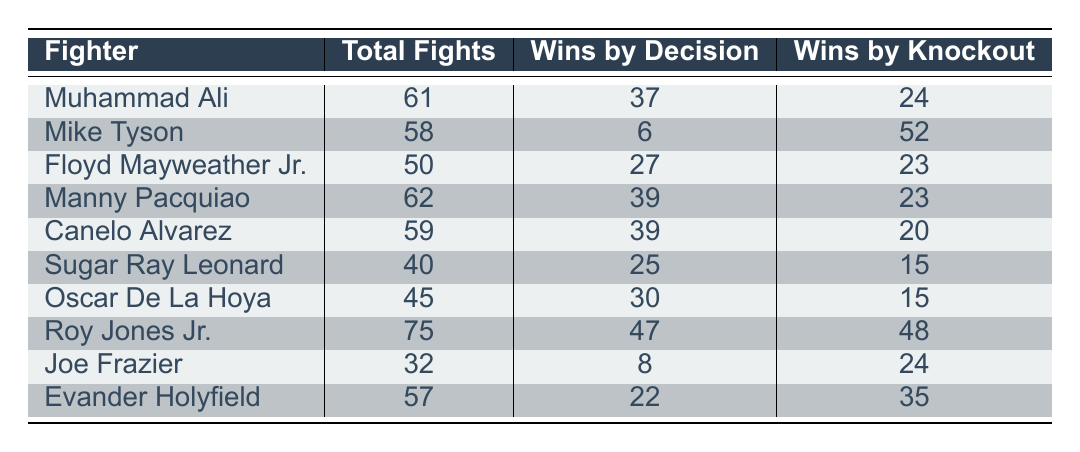What is the total number of fights won by Muhammad Ali? The table shows that Muhammad Ali had a total of 61 fights. Among these fights, he won 37 by decision and 24 by knockout. To find the total number of wins, we simply recognize that the table lists his total fights, and we look at the "wins by decision" and "wins by knockout" columns. Therefore, his total number of wins is 37 + 24 = 61.
Answer: 61 Which fighter has the highest number of wins by knockout? According to the table, Mike Tyson has 52 wins by knockout, which is more than any other fighter. We can see that while other fighters also have wins by knockout, none of them exceeds Tyson's total.
Answer: Mike Tyson How many more wins by decision does Manny Pacquiao have compared to Oscar De La Hoya? From the table, Manny Pacquiao has 39 wins by decision, while Oscar De La Hoya has 30 wins by decision. To find the difference, we subtract De La Hoya's wins from Pacquiao's wins: 39 - 30 = 9.
Answer: 9 Is it true that Floyd Mayweather Jr. has more wins by decision than Mike Tyson? If we look at the table, Floyd Mayweather Jr. has 27 wins by decision, while Mike Tyson has only 6 wins by decision. Since 27 is greater than 6, the statement is true.
Answer: Yes What percentage of total fights did Evander Holyfield win by knockout? Evander Holyfield has 57 total fights and 35 wins by knockout. To find the percentage of wins by knockout, we use the formula: (wins by knockout / total fights) * 100. So, (35 / 57) * 100 gives approximately 61.40%. This means about 61.40% of his fights were won by knockout.
Answer: 61.40% 